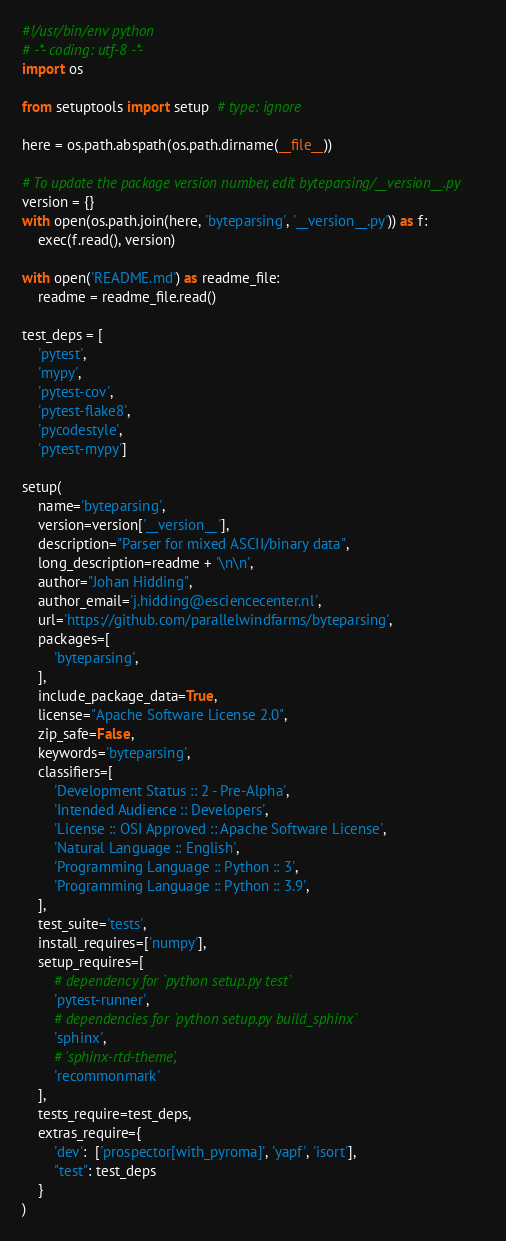<code> <loc_0><loc_0><loc_500><loc_500><_Python_>#!/usr/bin/env python
# -*- coding: utf-8 -*-
import os

from setuptools import setup  # type: ignore

here = os.path.abspath(os.path.dirname(__file__))

# To update the package version number, edit byteparsing/__version__.py
version = {}
with open(os.path.join(here, 'byteparsing', '__version__.py')) as f:
    exec(f.read(), version)

with open('README.md') as readme_file:
    readme = readme_file.read()

test_deps = [
    'pytest',
    'mypy',
    'pytest-cov',
    'pytest-flake8',
    'pycodestyle',
    'pytest-mypy']

setup(
    name='byteparsing',
    version=version['__version__'],
    description="Parser for mixed ASCII/binary data",
    long_description=readme + '\n\n',
    author="Johan Hidding",
    author_email='j.hidding@esciencecenter.nl',
    url='https://github.com/parallelwindfarms/byteparsing',
    packages=[
        'byteparsing',
    ],
    include_package_data=True,
    license="Apache Software License 2.0",
    zip_safe=False,
    keywords='byteparsing',
    classifiers=[
        'Development Status :: 2 - Pre-Alpha',
        'Intended Audience :: Developers',
        'License :: OSI Approved :: Apache Software License',
        'Natural Language :: English',
        'Programming Language :: Python :: 3',
        'Programming Language :: Python :: 3.9',
    ],
    test_suite='tests',
    install_requires=['numpy'],
    setup_requires=[
        # dependency for `python setup.py test`
        'pytest-runner',
        # dependencies for `python setup.py build_sphinx`
        'sphinx',
        # 'sphinx-rtd-theme',
        'recommonmark'
    ],
    tests_require=test_deps,
    extras_require={
        'dev':  ['prospector[with_pyroma]', 'yapf', 'isort'],
        "test": test_deps
    }
)
</code> 